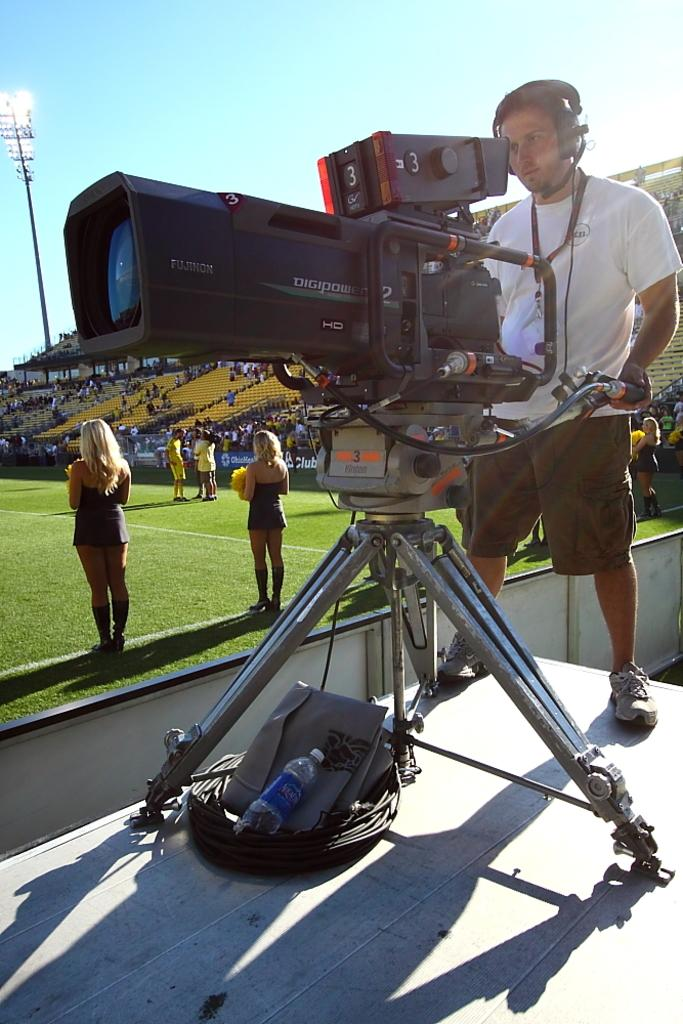<image>
Give a short and clear explanation of the subsequent image. The Fujinon camera used by the camera man  records in HD. 